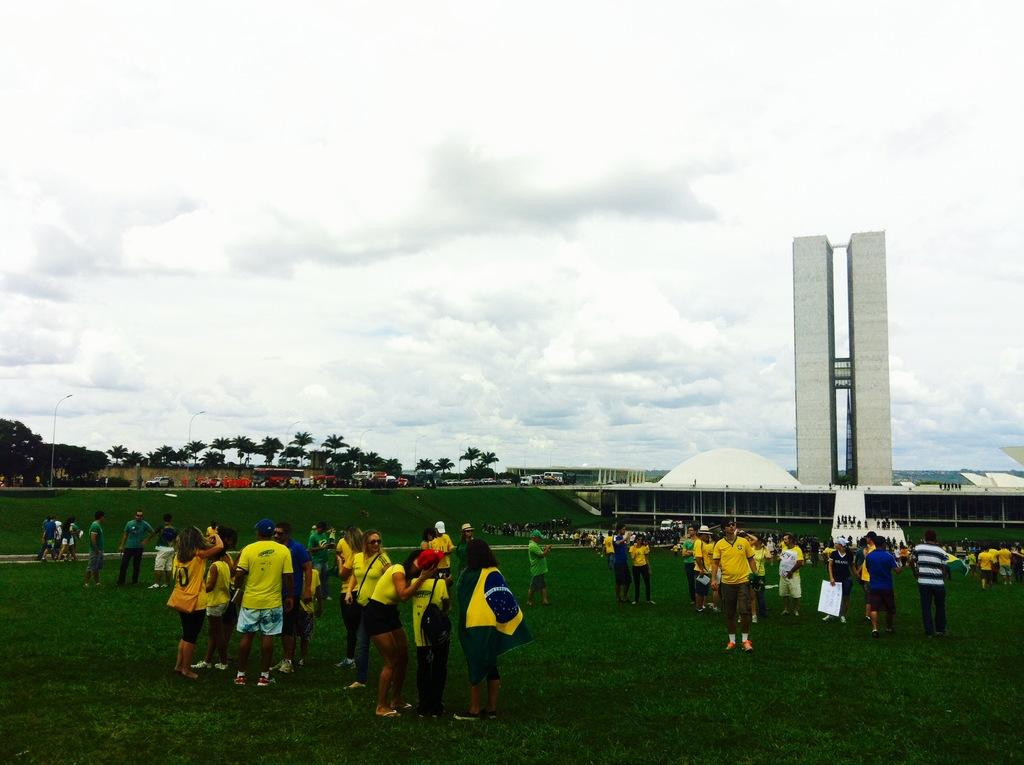What are the people in the image doing? The people in the image are standing on the ground. What can be seen in the background of the image? There is a building and trees visible in the image. What type of vehicles are present in the image? There are cars in the image. What is the texture of the ground in the image? The ground in the image has grass on it. How would you describe the sky in the image? The sky in the image is blue and cloudy. Where is the son sitting and eating lunch in the image? There is no son or lunchroom present in the image. What type of hydrant can be seen in the image? There is no hydrant present in the image. 